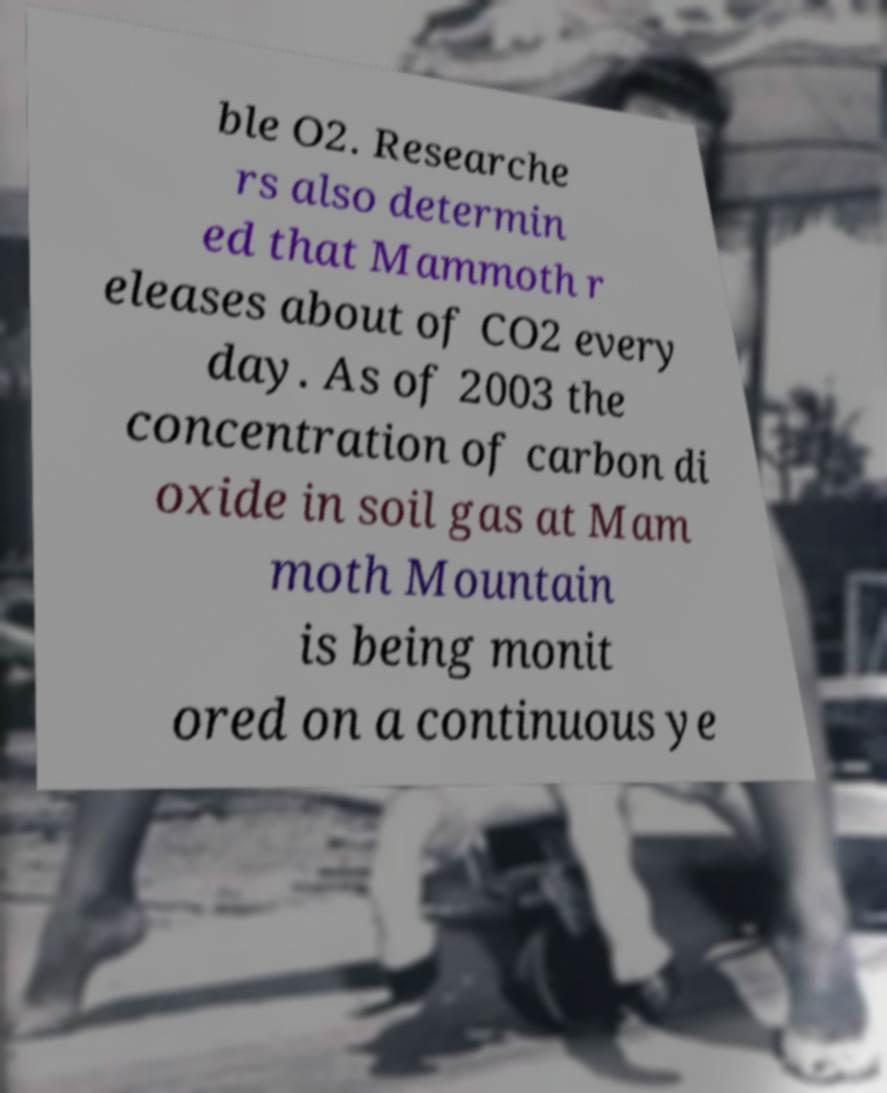Could you extract and type out the text from this image? ble O2. Researche rs also determin ed that Mammoth r eleases about of CO2 every day. As of 2003 the concentration of carbon di oxide in soil gas at Mam moth Mountain is being monit ored on a continuous ye 